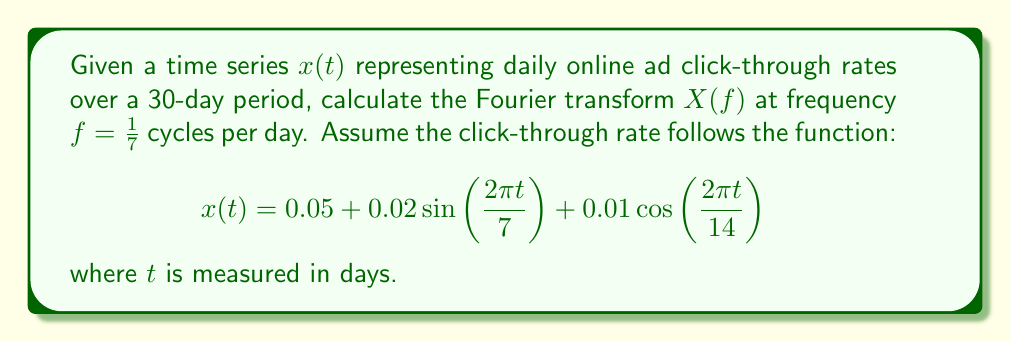Can you solve this math problem? To solve this problem, we'll follow these steps:

1) Recall the Fourier transform formula:
   $$X(f) = \int_{-\infty}^{\infty} x(t)e^{-i2\pi ft}dt$$

2) We need to calculate $X(f)$ at $f = 1/7$. Substituting our $x(t)$ and $f$:
   $$X(1/7) = \int_{-\infty}^{\infty} (0.05 + 0.02\sin(2\pi t/7) + 0.01\cos(2\pi t/14))e^{-i2\pi t/7}dt$$

3) Break this into three integrals:
   $$X(1/7) = \int_{-\infty}^{\infty} 0.05e^{-i2\pi t/7}dt + \int_{-\infty}^{\infty} 0.02\sin(2\pi t/7)e^{-i2\pi t/7}dt + \int_{-\infty}^{\infty} 0.01\cos(2\pi t/14)e^{-i2\pi t/7}dt$$

4) The first integral is a delta function:
   $$0.05 \int_{-\infty}^{\infty} e^{-i2\pi t/7}dt = 0.05 \cdot 7 \delta(f-1/7) = 0.35\delta(0) = 0.35$$

5) For the second integral, recall that $\sin(2\pi t/7) = \frac{1}{2i}(e^{i2\pi t/7} - e^{-i2\pi t/7})$:
   $$0.02 \int_{-\infty}^{\infty} \frac{1}{2i}(e^{i2\pi t/7} - e^{-i2\pi t/7})e^{-i2\pi t/7}dt = 0.02 \cdot \frac{7}{2i}(\delta(f) - \delta(f-2/7)) = 0.07i$$

6) The third integral involves $\cos(2\pi t/14) = \frac{1}{2}(e^{i\pi t/7} + e^{-i\pi t/7})$:
   $$0.01 \int_{-\infty}^{\infty} \frac{1}{2}(e^{i\pi t/7} + e^{-i\pi t/7})e^{-i2\pi t/7}dt = 0.01 \cdot \frac{7}{2}(\delta(f-1/14) + \delta(f-3/14)) = 0$$

7) Sum the results:
   $$X(1/7) = 0.35 + 0.07i + 0 = 0.35 + 0.07i$$
Answer: $0.35 + 0.07i$ 